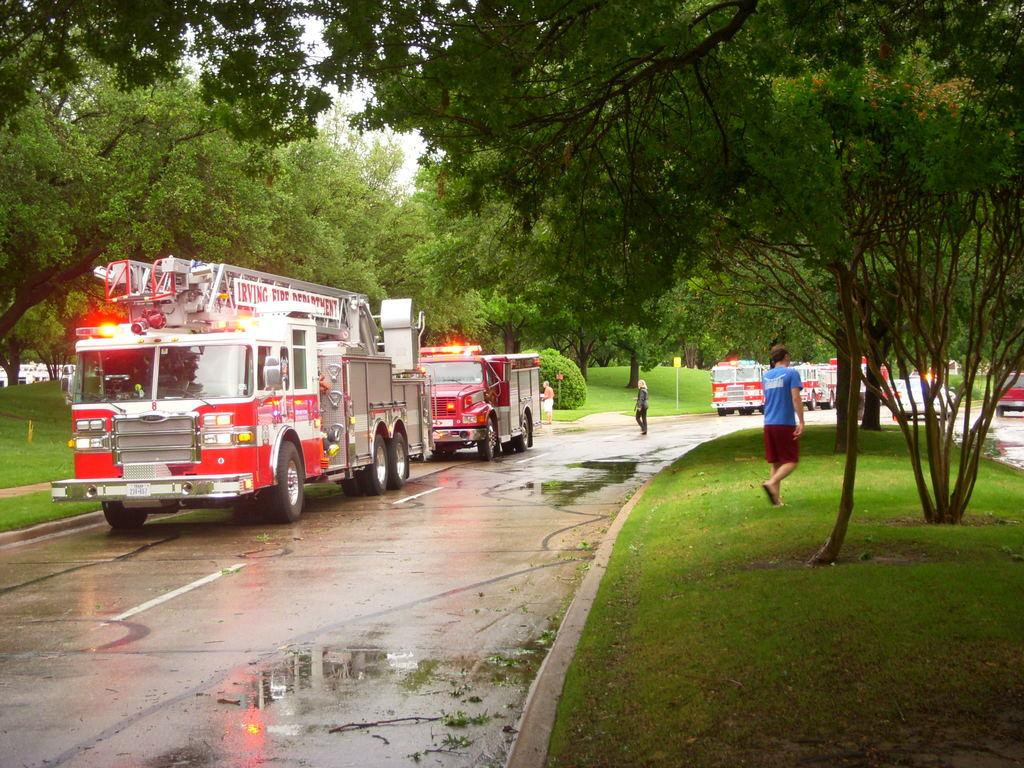What type of vehicles are on the road in the image? There are fire engines on the road in the image. What is the condition of the road in the image? There is water on the road in the image. What are the people in the image doing? There are people walking in the image. What type of vegetation can be seen in the background of the image? There are trees visible in the background of the image. What else can be seen in the background of the image? There is grass visible in the background of the image. What type of bubble is floating in the air in the image? There is no bubble present in the image. What scientific experiment is being conducted in the image? There is no scientific experiment depicted in the image. 